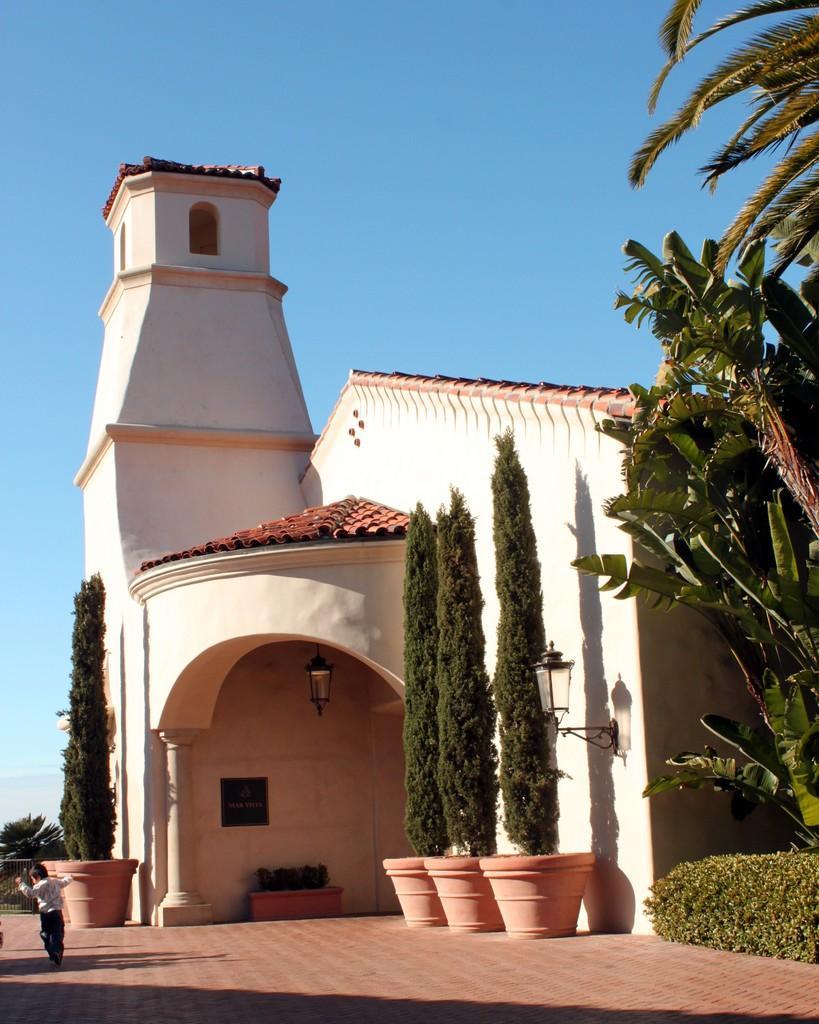In one or two sentences, can you explain what this image depicts? In this picture we can see house, trees, pots and plants. There is a person and we can see fence and lights. In the background of the image we can see the sky in blue color. 